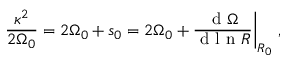Convert formula to latex. <formula><loc_0><loc_0><loc_500><loc_500>\frac { \kappa ^ { 2 } } { 2 { \Omega } _ { 0 } } = 2 { \Omega } _ { 0 } + s _ { 0 } = 2 { \Omega } _ { 0 } + \frac { d { \Omega } } { d l n R } \Big | _ { R _ { 0 } } \, ,</formula> 